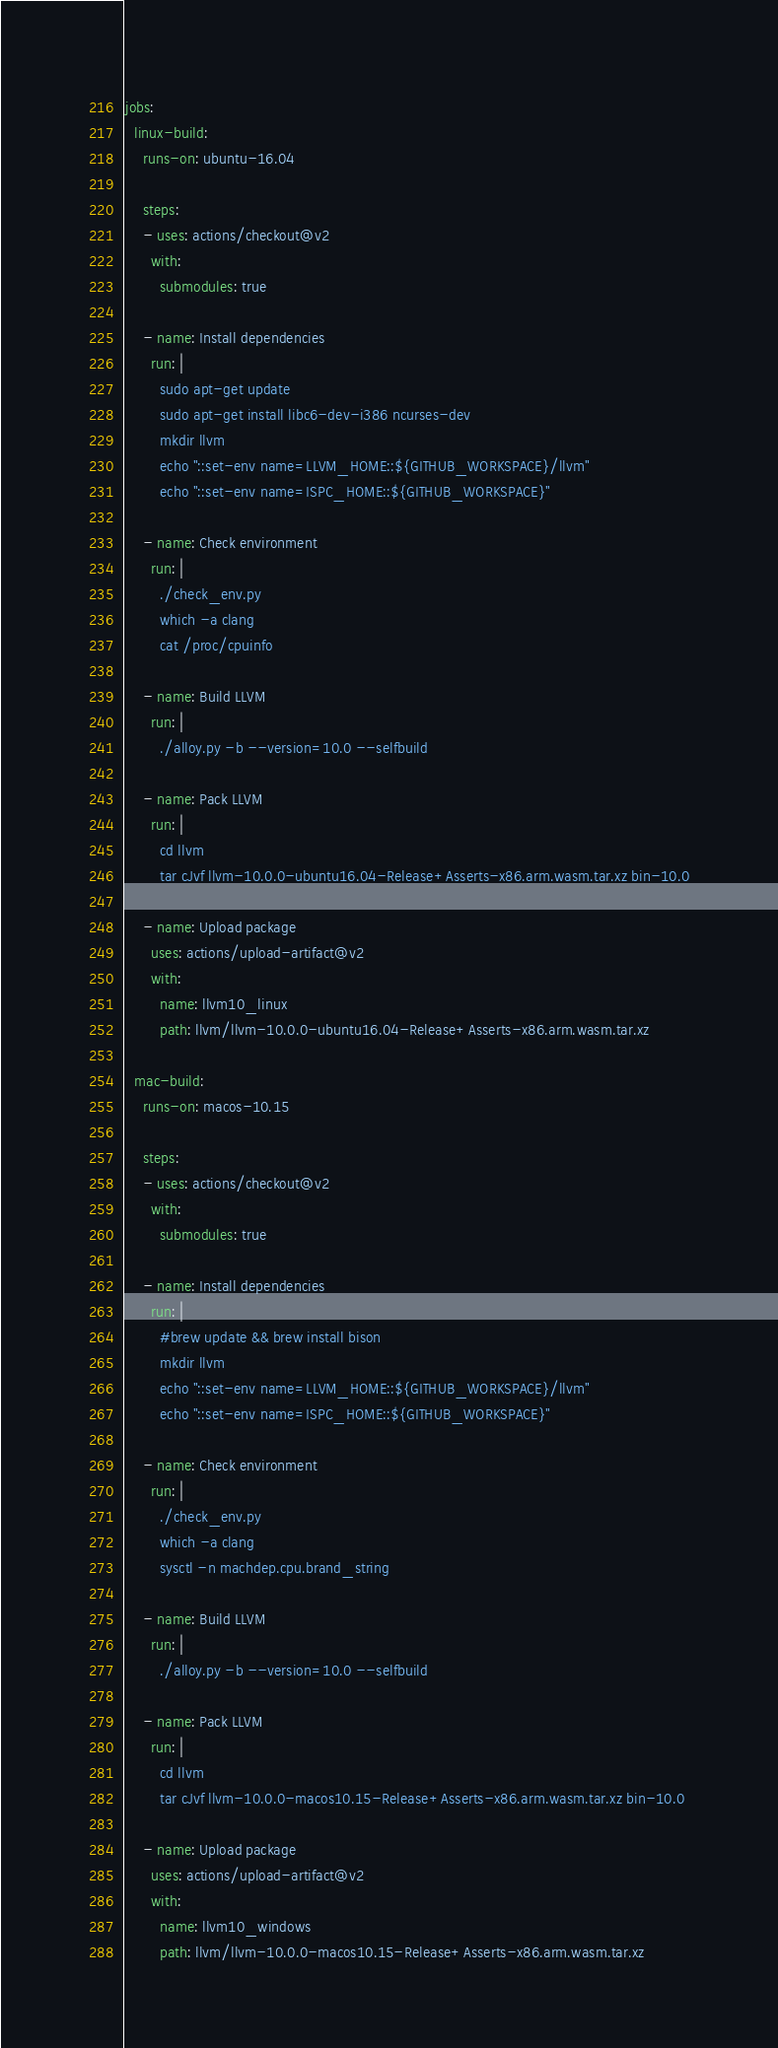Convert code to text. <code><loc_0><loc_0><loc_500><loc_500><_YAML_>jobs:
  linux-build:
    runs-on: ubuntu-16.04

    steps:
    - uses: actions/checkout@v2
      with:
        submodules: true

    - name: Install dependencies
      run: |
        sudo apt-get update
        sudo apt-get install libc6-dev-i386 ncurses-dev
        mkdir llvm
        echo "::set-env name=LLVM_HOME::${GITHUB_WORKSPACE}/llvm"
        echo "::set-env name=ISPC_HOME::${GITHUB_WORKSPACE}"

    - name: Check environment
      run: |
        ./check_env.py
        which -a clang
        cat /proc/cpuinfo

    - name: Build LLVM
      run: |
        ./alloy.py -b --version=10.0 --selfbuild

    - name: Pack LLVM
      run: |
        cd llvm
        tar cJvf llvm-10.0.0-ubuntu16.04-Release+Asserts-x86.arm.wasm.tar.xz bin-10.0

    - name: Upload package
      uses: actions/upload-artifact@v2
      with:
        name: llvm10_linux
        path: llvm/llvm-10.0.0-ubuntu16.04-Release+Asserts-x86.arm.wasm.tar.xz

  mac-build:
    runs-on: macos-10.15

    steps:
    - uses: actions/checkout@v2
      with:
        submodules: true

    - name: Install dependencies
      run: |
        #brew update && brew install bison
        mkdir llvm
        echo "::set-env name=LLVM_HOME::${GITHUB_WORKSPACE}/llvm"
        echo "::set-env name=ISPC_HOME::${GITHUB_WORKSPACE}"

    - name: Check environment
      run: |
        ./check_env.py
        which -a clang
        sysctl -n machdep.cpu.brand_string

    - name: Build LLVM
      run: |
        ./alloy.py -b --version=10.0 --selfbuild

    - name: Pack LLVM
      run: |
        cd llvm
        tar cJvf llvm-10.0.0-macos10.15-Release+Asserts-x86.arm.wasm.tar.xz bin-10.0

    - name: Upload package
      uses: actions/upload-artifact@v2
      with:
        name: llvm10_windows
        path: llvm/llvm-10.0.0-macos10.15-Release+Asserts-x86.arm.wasm.tar.xz

</code> 